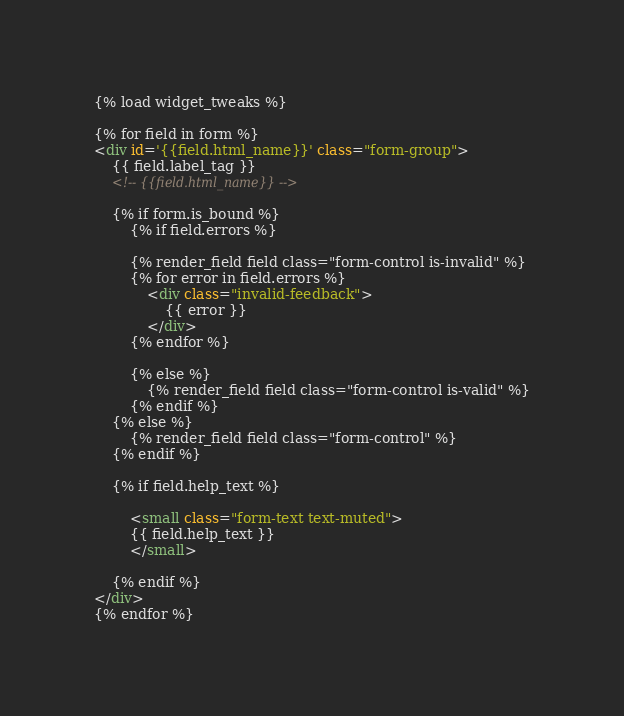<code> <loc_0><loc_0><loc_500><loc_500><_HTML_>{% load widget_tweaks %}

{% for field in form %}
<div id='{{field.html_name}}' class="form-group">
    {{ field.label_tag }}
    <!-- {{field.html_name}} -->

    {% if form.is_bound %}
        {% if field.errors %}

        {% render_field field class="form-control is-invalid" %}
        {% for error in field.errors %}
            <div class="invalid-feedback">
                {{ error }}
            </div>
        {% endfor %}
        
        {% else %}
            {% render_field field class="form-control is-valid" %}
        {% endif %}
    {% else %}
        {% render_field field class="form-control" %}
    {% endif %}

    {% if field.help_text %}

        <small class="form-text text-muted">
        {{ field.help_text }}
        </small>

    {% endif %}
</div>
{% endfor %}</code> 